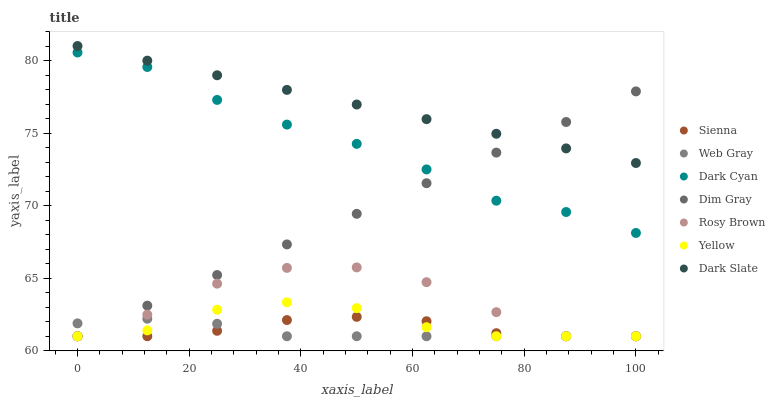Does Web Gray have the minimum area under the curve?
Answer yes or no. Yes. Does Dark Slate have the maximum area under the curve?
Answer yes or no. Yes. Does Rosy Brown have the minimum area under the curve?
Answer yes or no. No. Does Rosy Brown have the maximum area under the curve?
Answer yes or no. No. Is Dim Gray the smoothest?
Answer yes or no. Yes. Is Rosy Brown the roughest?
Answer yes or no. Yes. Is Yellow the smoothest?
Answer yes or no. No. Is Yellow the roughest?
Answer yes or no. No. Does Dim Gray have the lowest value?
Answer yes or no. Yes. Does Dark Slate have the lowest value?
Answer yes or no. No. Does Dark Slate have the highest value?
Answer yes or no. Yes. Does Rosy Brown have the highest value?
Answer yes or no. No. Is Dark Cyan less than Dark Slate?
Answer yes or no. Yes. Is Dark Cyan greater than Sienna?
Answer yes or no. Yes. Does Yellow intersect Web Gray?
Answer yes or no. Yes. Is Yellow less than Web Gray?
Answer yes or no. No. Is Yellow greater than Web Gray?
Answer yes or no. No. Does Dark Cyan intersect Dark Slate?
Answer yes or no. No. 